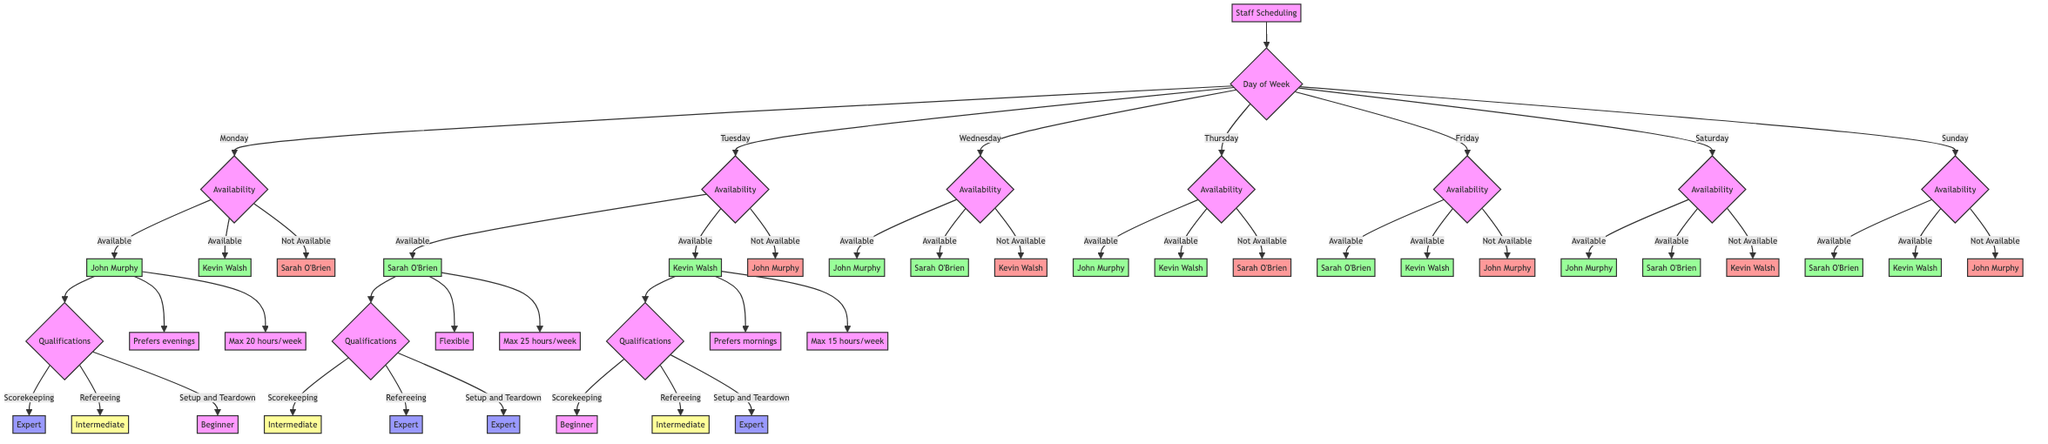What is John Murphy's availability on Friday? The diagram shows that John Murphy is "Not Available" on Friday. This is directly indicated under the availability section for that day in the diagram.
Answer: Not Available Which staff member has the maximum weekly hour limit? By checking the maximum hour limits for each staff member, Sarah O'Brien has a maximum of 25 hours per week, which is higher than John Murphy's 20 and Kevin Walsh's 15.
Answer: 25 hours per week How many staff members are available on Saturday? On Saturday, both John Murphy and Sarah O'Brien are marked as "Available" while Kevin Walsh is "Not Available". Therefore, the count of available staff is 2.
Answer: 2 What is Sarah O'Brien's qualification score for refereeing? The diagram specifies that Sarah O'Brien is an "Expert" in refereeing, as shown in the qualifications section.
Answer: Expert Who prefers mornings and what is their maximum hours limit? Kevin Walsh prefers mornings and has a maximum hours limit of 15 hours per week. This can be inferred by following the preference and maximum hours nodes linked to Kevin Walsh in the diagram.
Answer: Prefers mornings, 15 hours per week Which staff member is available for scorekeeping on Wednesday? On Wednesday, both John Murphy and Sarah O'Brien are marked as "Available". Checking their qualifications shows that John is an "Expert" and Sarah is "Intermediate" in scorekeeping, thus both can perform that role.
Answer: John Murphy, Sarah O'Brien What are the qualifications related to setup and teardown for Kevin Walsh? Kevin Walsh's qualifications for setup and teardown show that he is an "Expert". This specific qualification can be found in the qualifications section of the diagram.
Answer: Expert How many staff members are available on Thursday? According to the availability chart for Thursday, both John Murphy and Kevin Walsh are "Available", while Sarah O'Brien is "Not Available". Therefore, there are 2 staff members available.
Answer: 2 